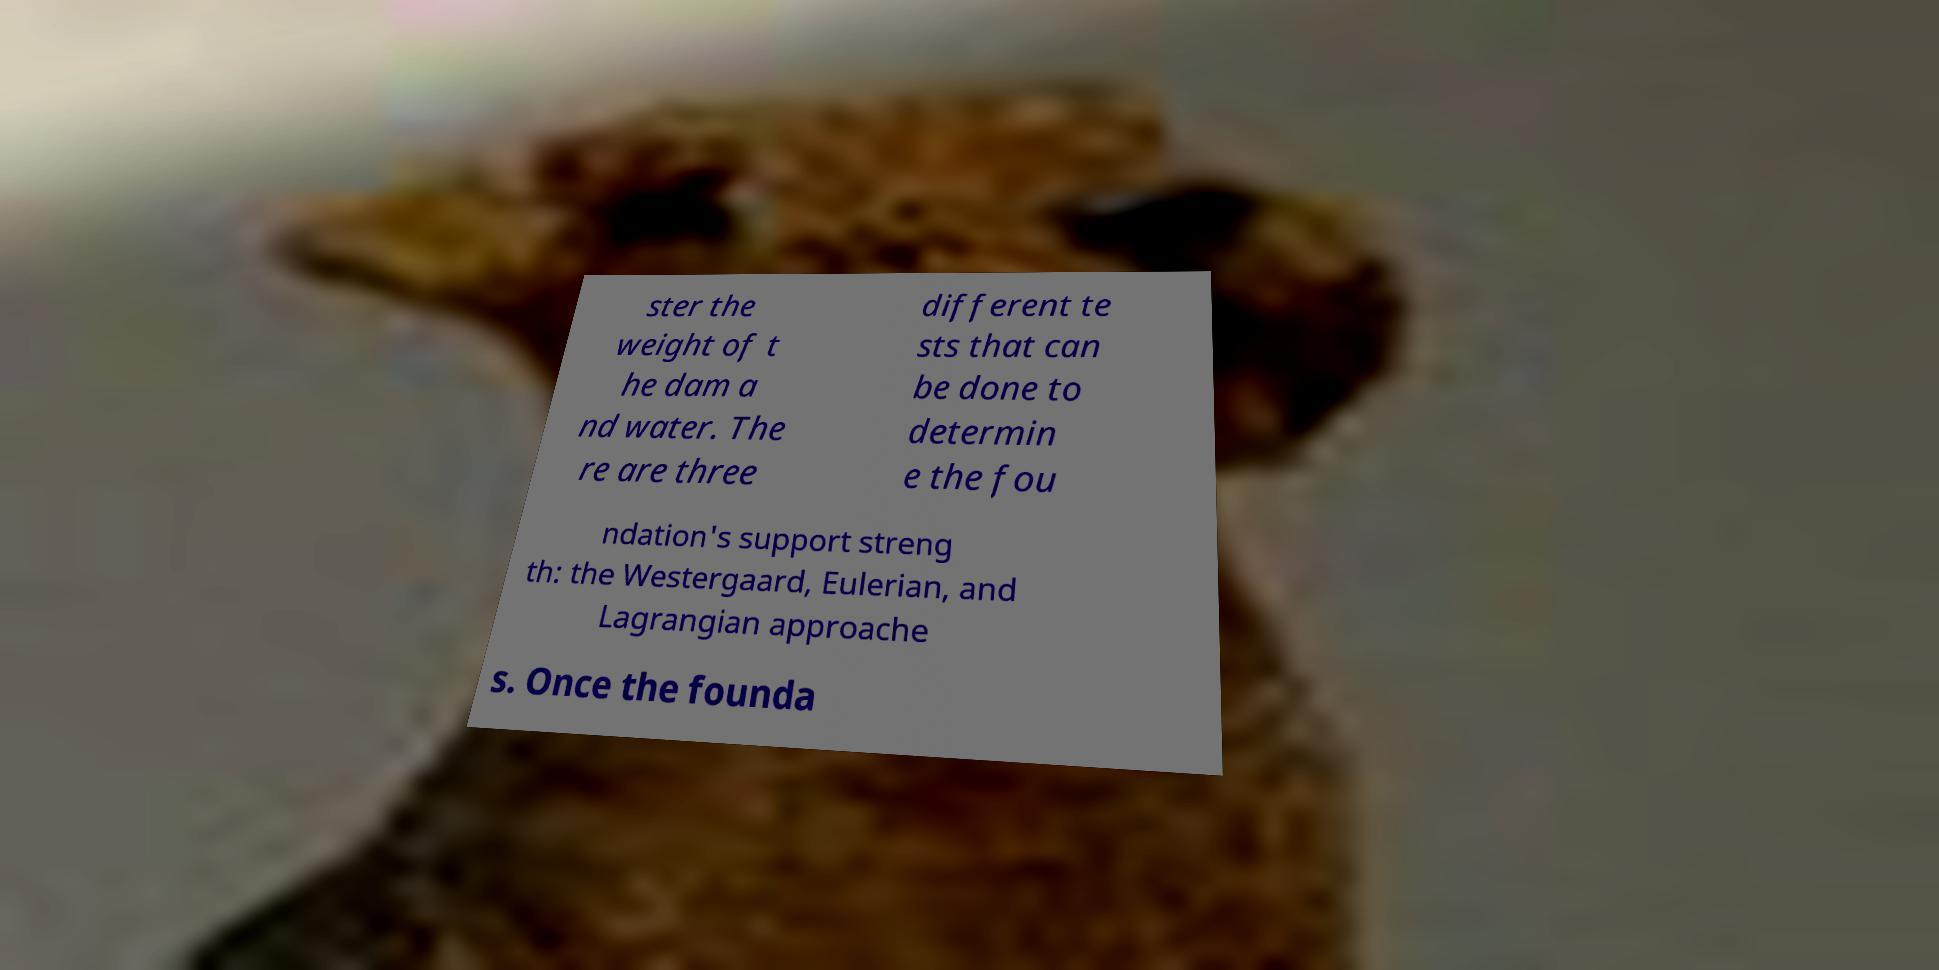Please identify and transcribe the text found in this image. ster the weight of t he dam a nd water. The re are three different te sts that can be done to determin e the fou ndation's support streng th: the Westergaard, Eulerian, and Lagrangian approache s. Once the founda 